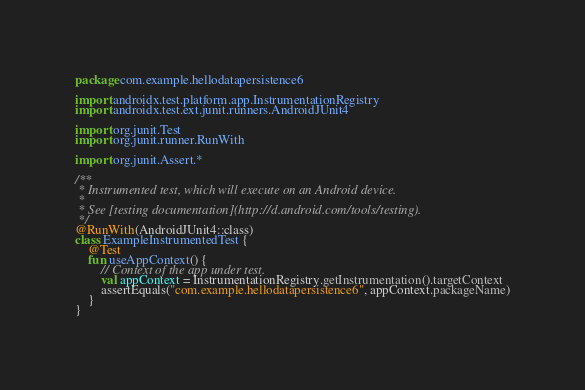<code> <loc_0><loc_0><loc_500><loc_500><_Kotlin_>package com.example.hellodatapersistence6

import androidx.test.platform.app.InstrumentationRegistry
import androidx.test.ext.junit.runners.AndroidJUnit4

import org.junit.Test
import org.junit.runner.RunWith

import org.junit.Assert.*

/**
 * Instrumented test, which will execute on an Android device.
 *
 * See [testing documentation](http://d.android.com/tools/testing).
 */
@RunWith(AndroidJUnit4::class)
class ExampleInstrumentedTest {
    @Test
    fun useAppContext() {
        // Context of the app under test.
        val appContext = InstrumentationRegistry.getInstrumentation().targetContext
        assertEquals("com.example.hellodatapersistence6", appContext.packageName)
    }
}
</code> 